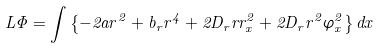<formula> <loc_0><loc_0><loc_500><loc_500>L \Phi = \int \left \{ - 2 a r ^ { 2 } + b _ { r } r ^ { 4 } + 2 D _ { r } r r ^ { 2 } _ { x } + 2 D _ { r } r ^ { 2 } \varphi ^ { 2 } _ { x } \right \} d x</formula> 